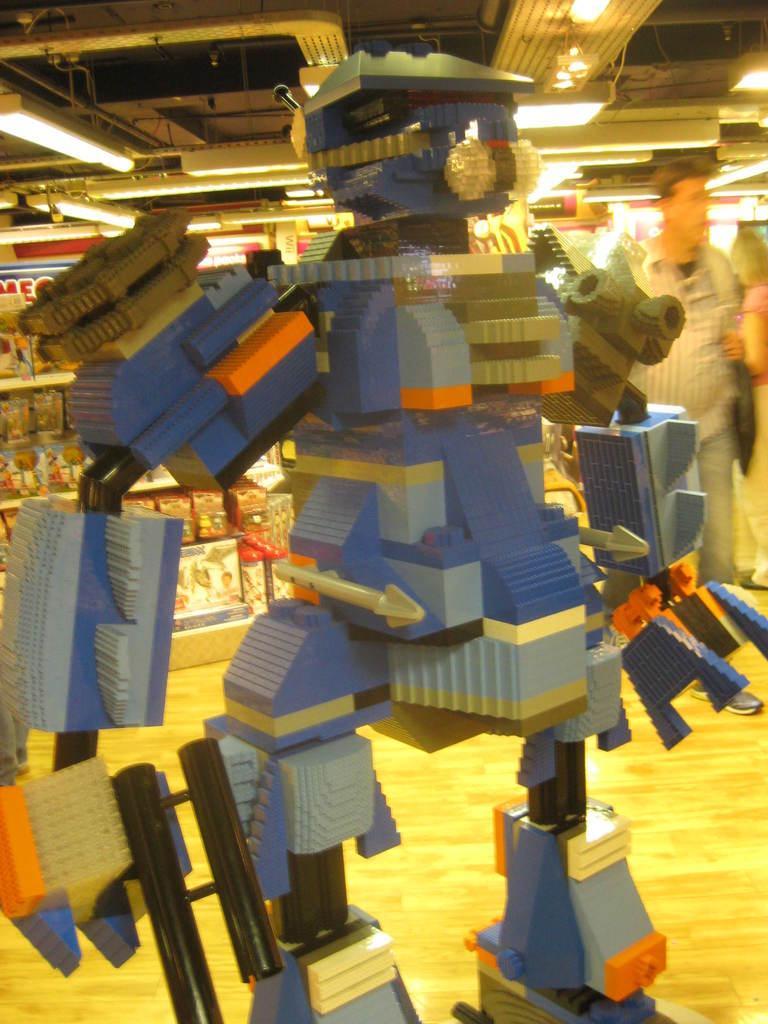Please provide a concise description of this image. In this picture I can see Lego toy in the foreground. I can see people on the right side. I can see toys on a rack shelf in the background. I can see light arrangements at the top. 